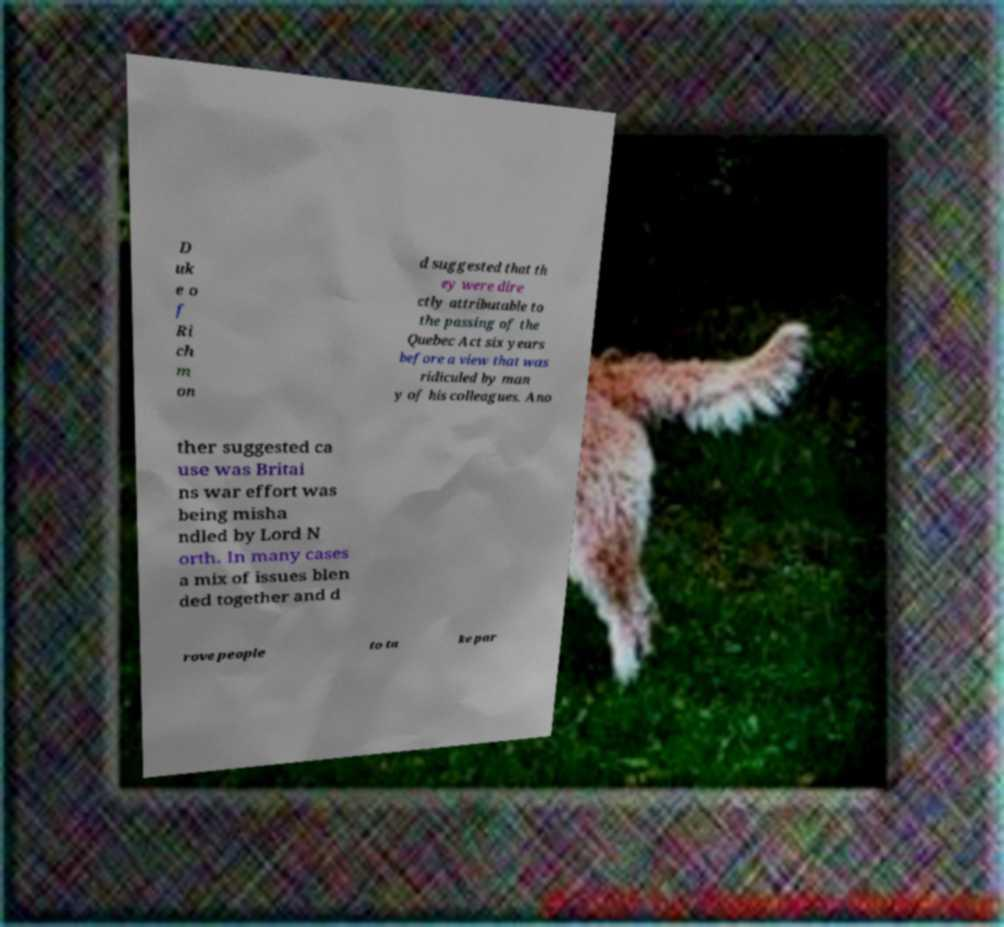Can you accurately transcribe the text from the provided image for me? D uk e o f Ri ch m on d suggested that th ey were dire ctly attributable to the passing of the Quebec Act six years before a view that was ridiculed by man y of his colleagues. Ano ther suggested ca use was Britai ns war effort was being misha ndled by Lord N orth. In many cases a mix of issues blen ded together and d rove people to ta ke par 